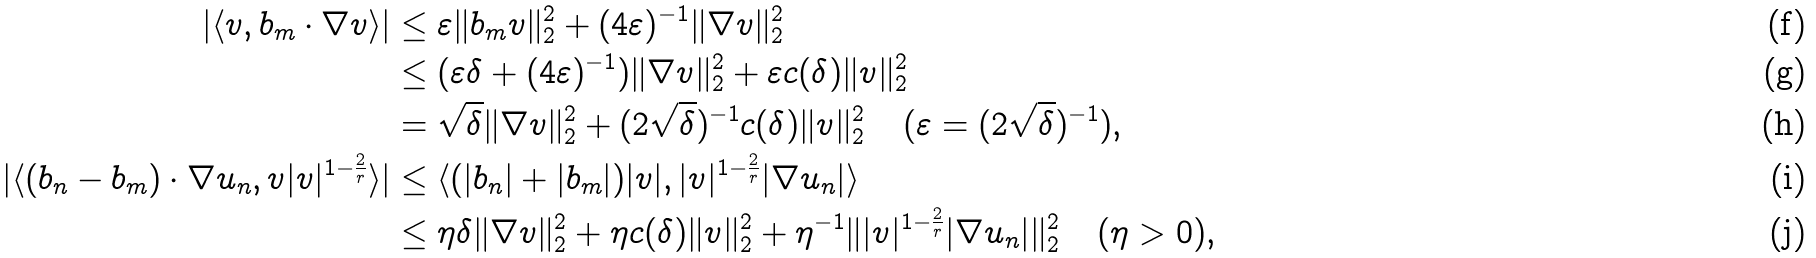Convert formula to latex. <formula><loc_0><loc_0><loc_500><loc_500>| \langle v , b _ { m } \cdot \nabla v \rangle | & \leq \varepsilon \| b _ { m } v \| _ { 2 } ^ { 2 } + ( 4 \varepsilon ) ^ { - 1 } \| \nabla v \| _ { 2 } ^ { 2 } \\ & \leq ( \varepsilon \delta + ( 4 \varepsilon ) ^ { - 1 } ) \| \nabla v \| _ { 2 } ^ { 2 } + \varepsilon c ( \delta ) \| v \| _ { 2 } ^ { 2 } \\ & = \sqrt { \delta } \| \nabla v \| _ { 2 } ^ { 2 } + ( 2 \sqrt { \delta } ) ^ { - 1 } c ( \delta ) \| v \| _ { 2 } ^ { 2 } \quad ( \varepsilon = ( 2 \sqrt { \delta } ) ^ { - 1 } ) , \\ | \langle ( b _ { n } - b _ { m } ) \cdot \nabla u _ { n } , v | v | ^ { 1 - \frac { 2 } { r } } \rangle | & \leq \langle ( | b _ { n } | + | b _ { m } | ) | v | , | v | ^ { 1 - \frac { 2 } { r } } | \nabla u _ { n } | \rangle \\ & \leq \eta \delta \| \nabla v \| _ { 2 } ^ { 2 } + \eta c ( \delta ) \| v \| _ { 2 } ^ { 2 } + \eta ^ { - 1 } \| | v | ^ { 1 - \frac { 2 } { r } } | \nabla u _ { n } | \| _ { 2 } ^ { 2 } \quad ( \eta > 0 ) ,</formula> 